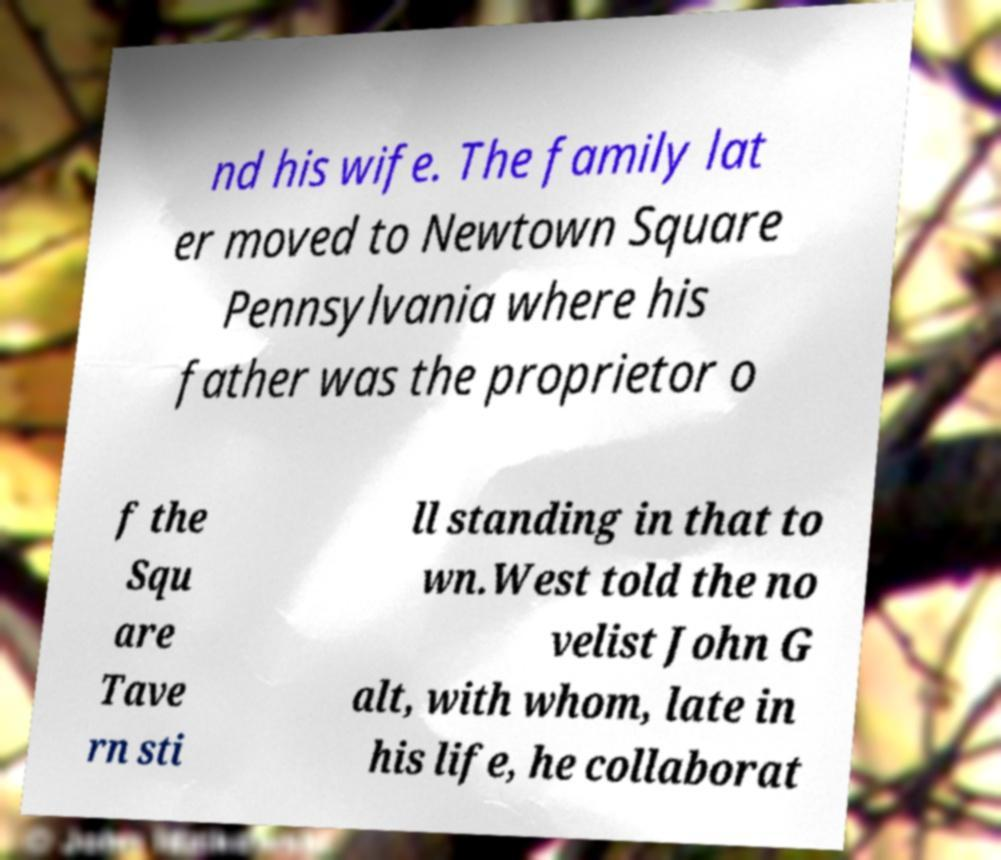Can you read and provide the text displayed in the image?This photo seems to have some interesting text. Can you extract and type it out for me? nd his wife. The family lat er moved to Newtown Square Pennsylvania where his father was the proprietor o f the Squ are Tave rn sti ll standing in that to wn.West told the no velist John G alt, with whom, late in his life, he collaborat 